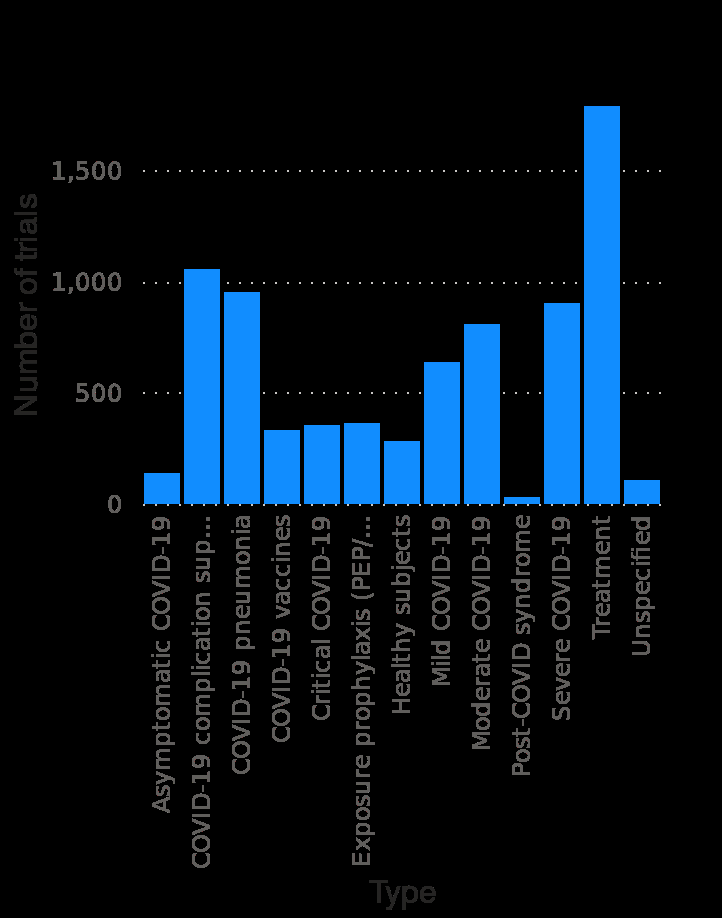<image>
please enumerates aspects of the construction of the chart This bar plot is called Number of coronavirus (COVID-19) clinical trials for drugs and vaccines worldwide as of January 7 , 2021 , by type. The x-axis shows Type as categorical scale starting at Asymptomatic COVID-19 and ending at  while the y-axis shows Number of trials on linear scale from 0 to 1,500. Is the x-axis of this line plot called Number of coronavirus (COVID-19) clinical trials for drugs and vaccines worldwide as of January 7, 2021, by type? No.This bar plot is called Number of coronavirus (COVID-19) clinical trials for drugs and vaccines worldwide as of January 7 , 2021 , by type. The x-axis shows Type as categorical scale starting at Asymptomatic COVID-19 and ending at  while the y-axis shows Number of trials on linear scale from 0 to 1,500. 